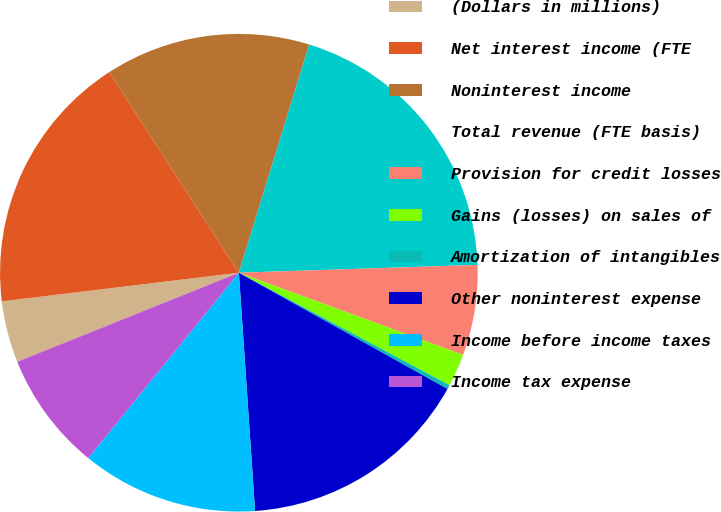<chart> <loc_0><loc_0><loc_500><loc_500><pie_chart><fcel>(Dollars in millions)<fcel>Net interest income (FTE<fcel>Noninterest income<fcel>Total revenue (FTE basis)<fcel>Provision for credit losses<fcel>Gains (losses) on sales of<fcel>Amortization of intangibles<fcel>Other noninterest expense<fcel>Income before income taxes<fcel>Income tax expense<nl><fcel>4.17%<fcel>17.78%<fcel>13.89%<fcel>19.72%<fcel>6.11%<fcel>2.22%<fcel>0.28%<fcel>15.83%<fcel>11.94%<fcel>8.06%<nl></chart> 